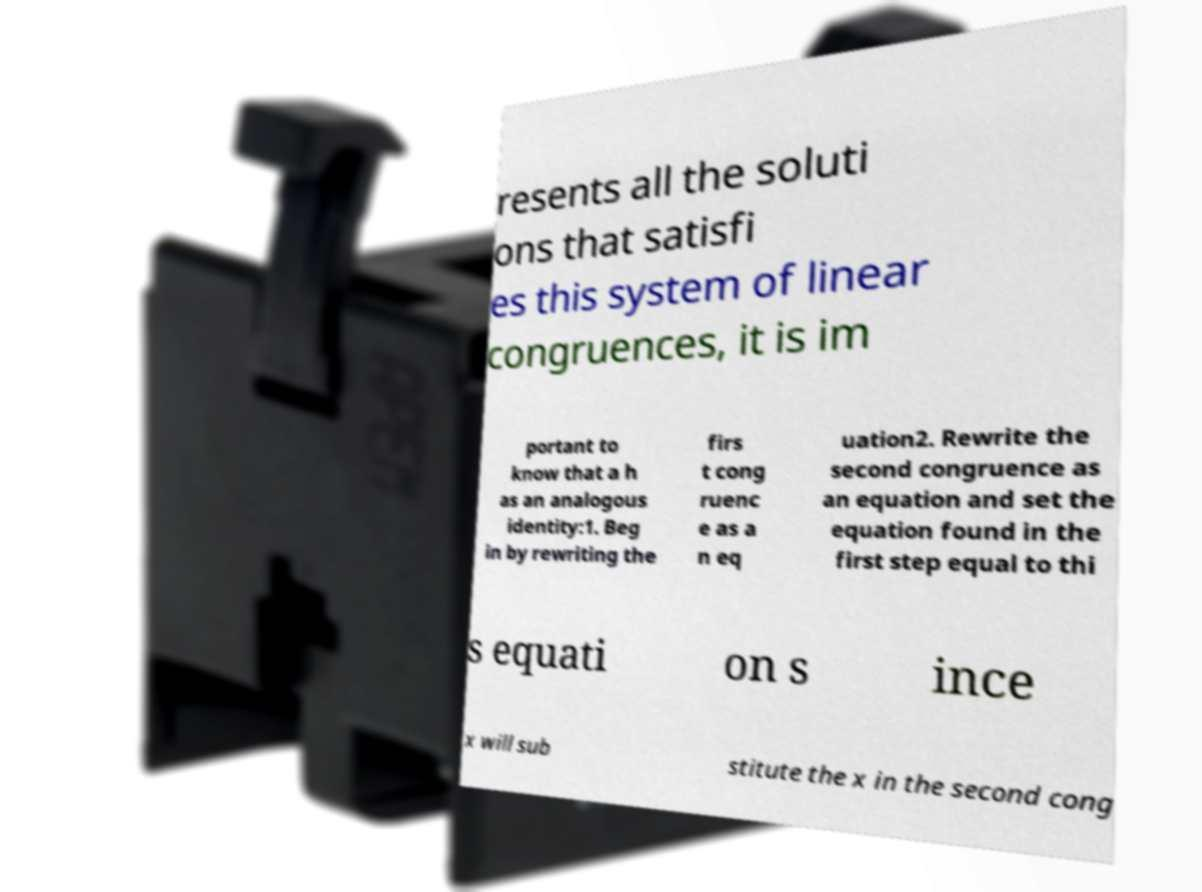What messages or text are displayed in this image? I need them in a readable, typed format. resents all the soluti ons that satisfi es this system of linear congruences, it is im portant to know that a h as an analogous identity:1. Beg in by rewriting the firs t cong ruenc e as a n eq uation2. Rewrite the second congruence as an equation and set the equation found in the first step equal to thi s equati on s ince x will sub stitute the x in the second cong 